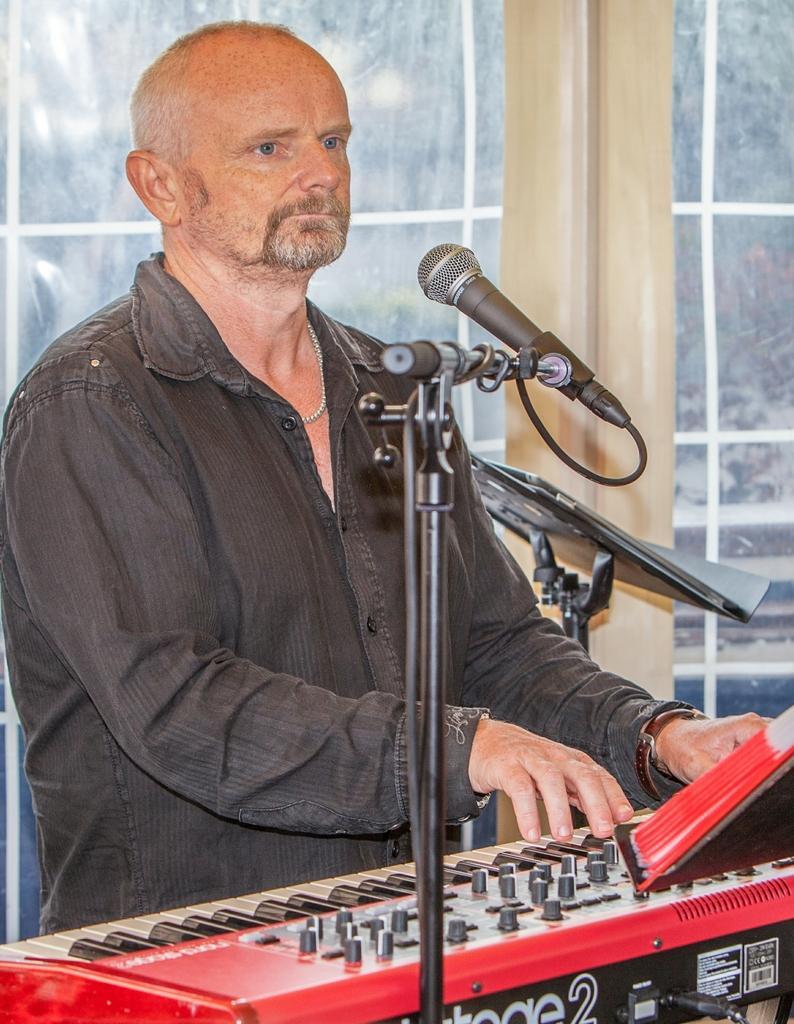Please provide a concise description of this image. In this picture we can see a man is playing a piano, there is a microphone in front of him, on the right side there is a music stand, in the background we can see glass. 